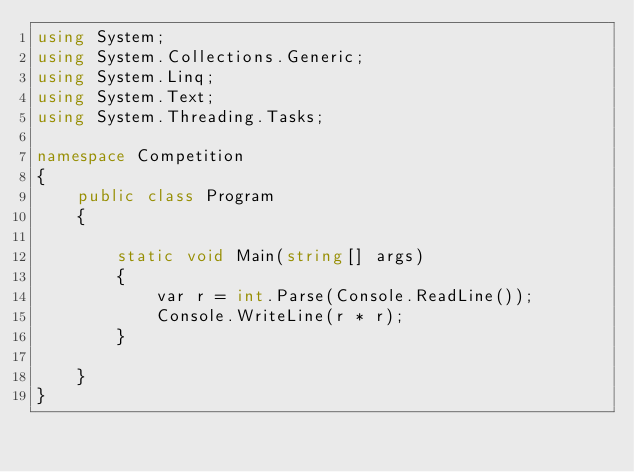Convert code to text. <code><loc_0><loc_0><loc_500><loc_500><_C#_>using System;
using System.Collections.Generic;
using System.Linq;
using System.Text;
using System.Threading.Tasks;

namespace Competition
{
    public class Program
    {
        
        static void Main(string[] args)
        {
            var r = int.Parse(Console.ReadLine());
            Console.WriteLine(r * r);
        }

    }
}
</code> 